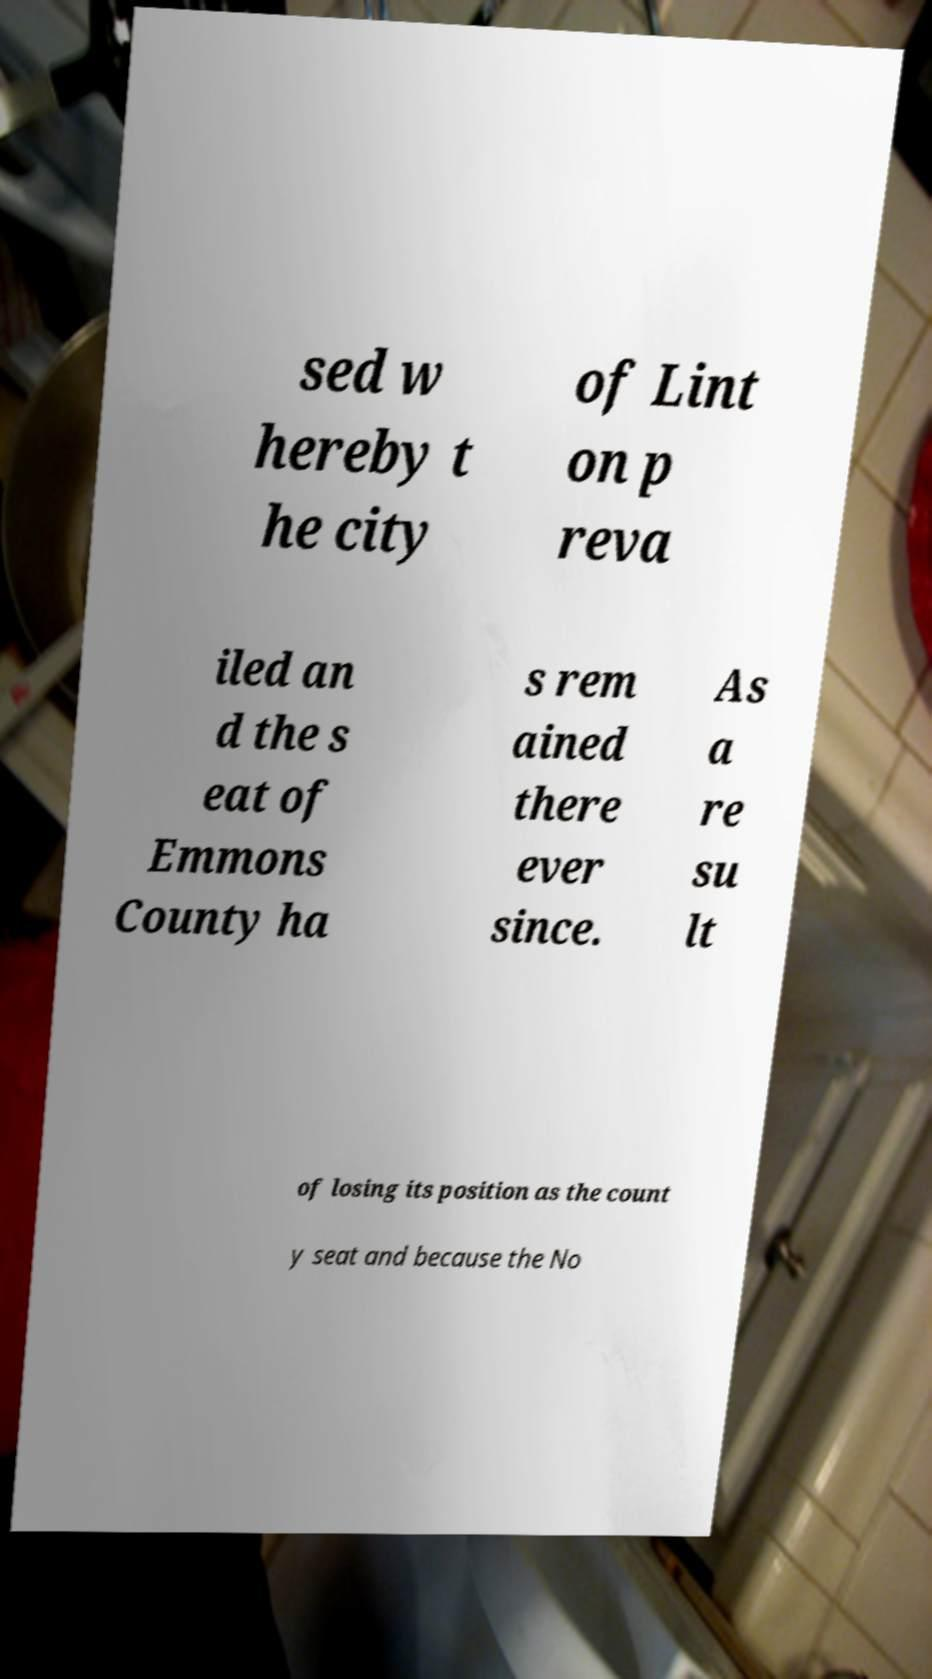What messages or text are displayed in this image? I need them in a readable, typed format. sed w hereby t he city of Lint on p reva iled an d the s eat of Emmons County ha s rem ained there ever since. As a re su lt of losing its position as the count y seat and because the No 